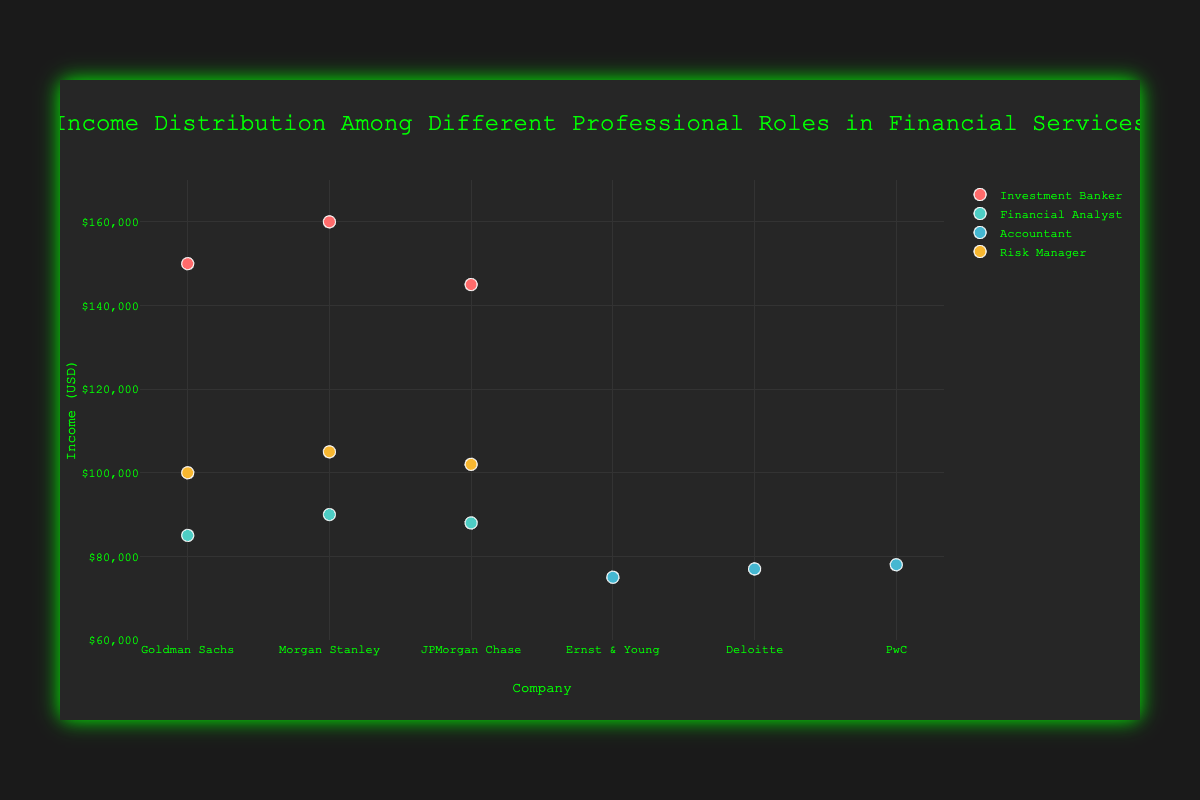What's the title of the chart? Look at the top of the chart where the title is located. It reads "Income Distribution Among Different Professional Roles in Financial Services."
Answer: Income Distribution Among Different Professional Roles in Financial Services What is the company with the highest income for Investment Bankers? Identify the Investment Banker roles and compare their incomes across different companies. The Investment Banker at Morgan Stanley has the highest income, which is $160,000.
Answer: Morgan Stanley Which professional role has the lowest income? Compare the incomes of all roles. The Accountants have the lowest incomes, with the lowest being $75,000 at Ernst & Young.
Answer: Accountant What is the average income of Financial Analysts? Sum the incomes of Financial Analysts: $85,000, $90,000, and $88,000. Then divide by the number of data points (3): (85,000 + 90,000 + 88,000) / 3 = 87,666.67.
Answer: $87,666.67 Is the median income of Risk Managers higher than $100,000? List the incomes of Risk Managers: $100,000, $105,000, and $102,000. The median is the middle value when ordered: $102,000.
Answer: Yes Which role has the largest income range? Calculate the range for each role: 
- Investment Banker: $160,000 - $145,000 = $15,000
- Financial Analyst: $90,000 - $85,000 = $5,000
- Accountant: $78,000 - $75,000 = $3,000
- Risk Manager: $105,000 - $100,000 = $5,000 
Investment Banker has the largest range.
Answer: Investment Banker How does the income of Risk Managers at Morgan Stanley compare to that at JPMorgan Chase? Compare their incomes directly. Morgan Stanley ($105,000) has higher income than JPMorgan Chase ($102,000).
Answer: Morgan Stanley has higher income What is the sum of incomes for Accountants? Add the incomes of Accountants: $75,000, $77,000, and $78,000, resulting in $75,000 + $77,000 + $78,000 = $230,000.
Answer: $230,000 Which role has more data points, Financial Analyst or Risk Manager? Count the number of data points for each role: Financial Analyst (3), Risk Manager (3). Both have an equal number of data points.
Answer: Equal If a new role had an income of $80,000, how many roles would then have incomes below $100,000? Identify current incomes below $100,000 which are all Financial Analysts and Accountants:
- Financial Analyst: $85,000, $90,000, $88,000
- Accountant: $75,000, $77,000, $78,000
These form 6 roles below $100,000. Adding one more role with $80,000 results in 6 + 1 = 7.
Answer: 7 